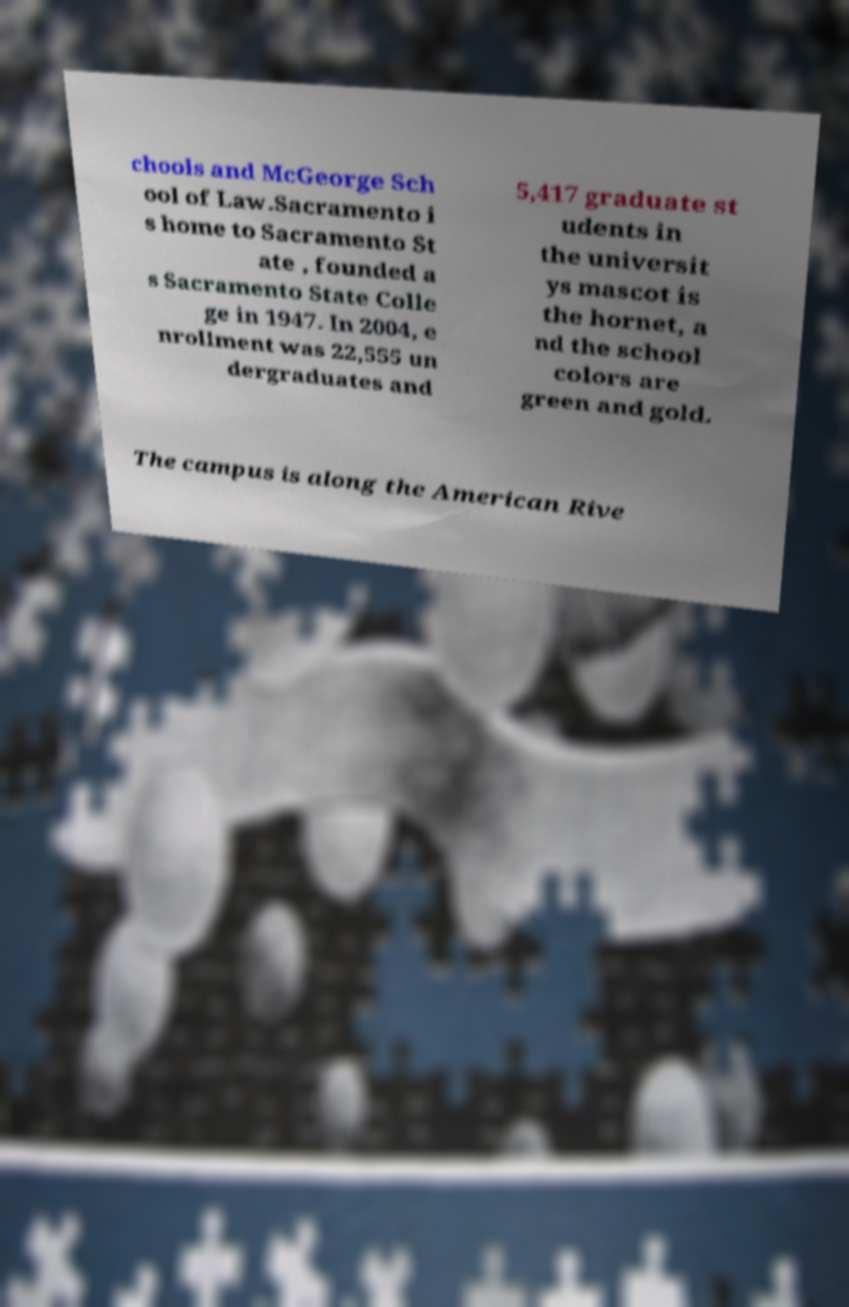Please read and relay the text visible in this image. What does it say? chools and McGeorge Sch ool of Law.Sacramento i s home to Sacramento St ate , founded a s Sacramento State Colle ge in 1947. In 2004, e nrollment was 22,555 un dergraduates and 5,417 graduate st udents in the universit ys mascot is the hornet, a nd the school colors are green and gold. The campus is along the American Rive 